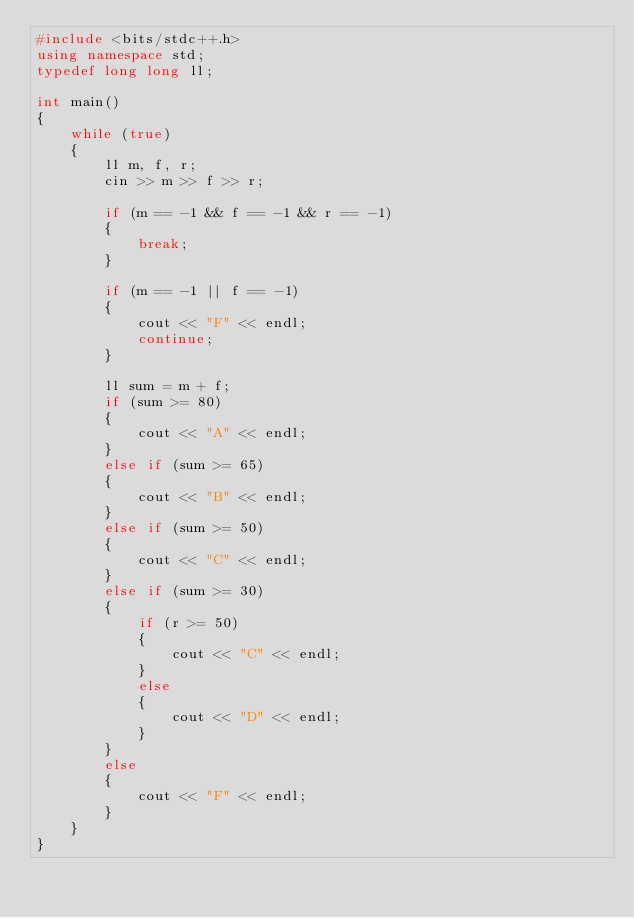<code> <loc_0><loc_0><loc_500><loc_500><_C++_>#include <bits/stdc++.h>
using namespace std;
typedef long long ll;

int main()
{
    while (true)
    {
        ll m, f, r;
        cin >> m >> f >> r;

        if (m == -1 && f == -1 && r == -1)
        {
            break;
        }

        if (m == -1 || f == -1)
        {
            cout << "F" << endl;
            continue;
        }

        ll sum = m + f;
        if (sum >= 80)
        {
            cout << "A" << endl;
        }
        else if (sum >= 65)
        {
            cout << "B" << endl;
        }
        else if (sum >= 50)
        {
            cout << "C" << endl;
        }
        else if (sum >= 30)
        {
            if (r >= 50)
            {
                cout << "C" << endl;
            }
            else
            {
                cout << "D" << endl;
            }
        }
        else
        {
            cout << "F" << endl;
        }
    }
}
</code> 